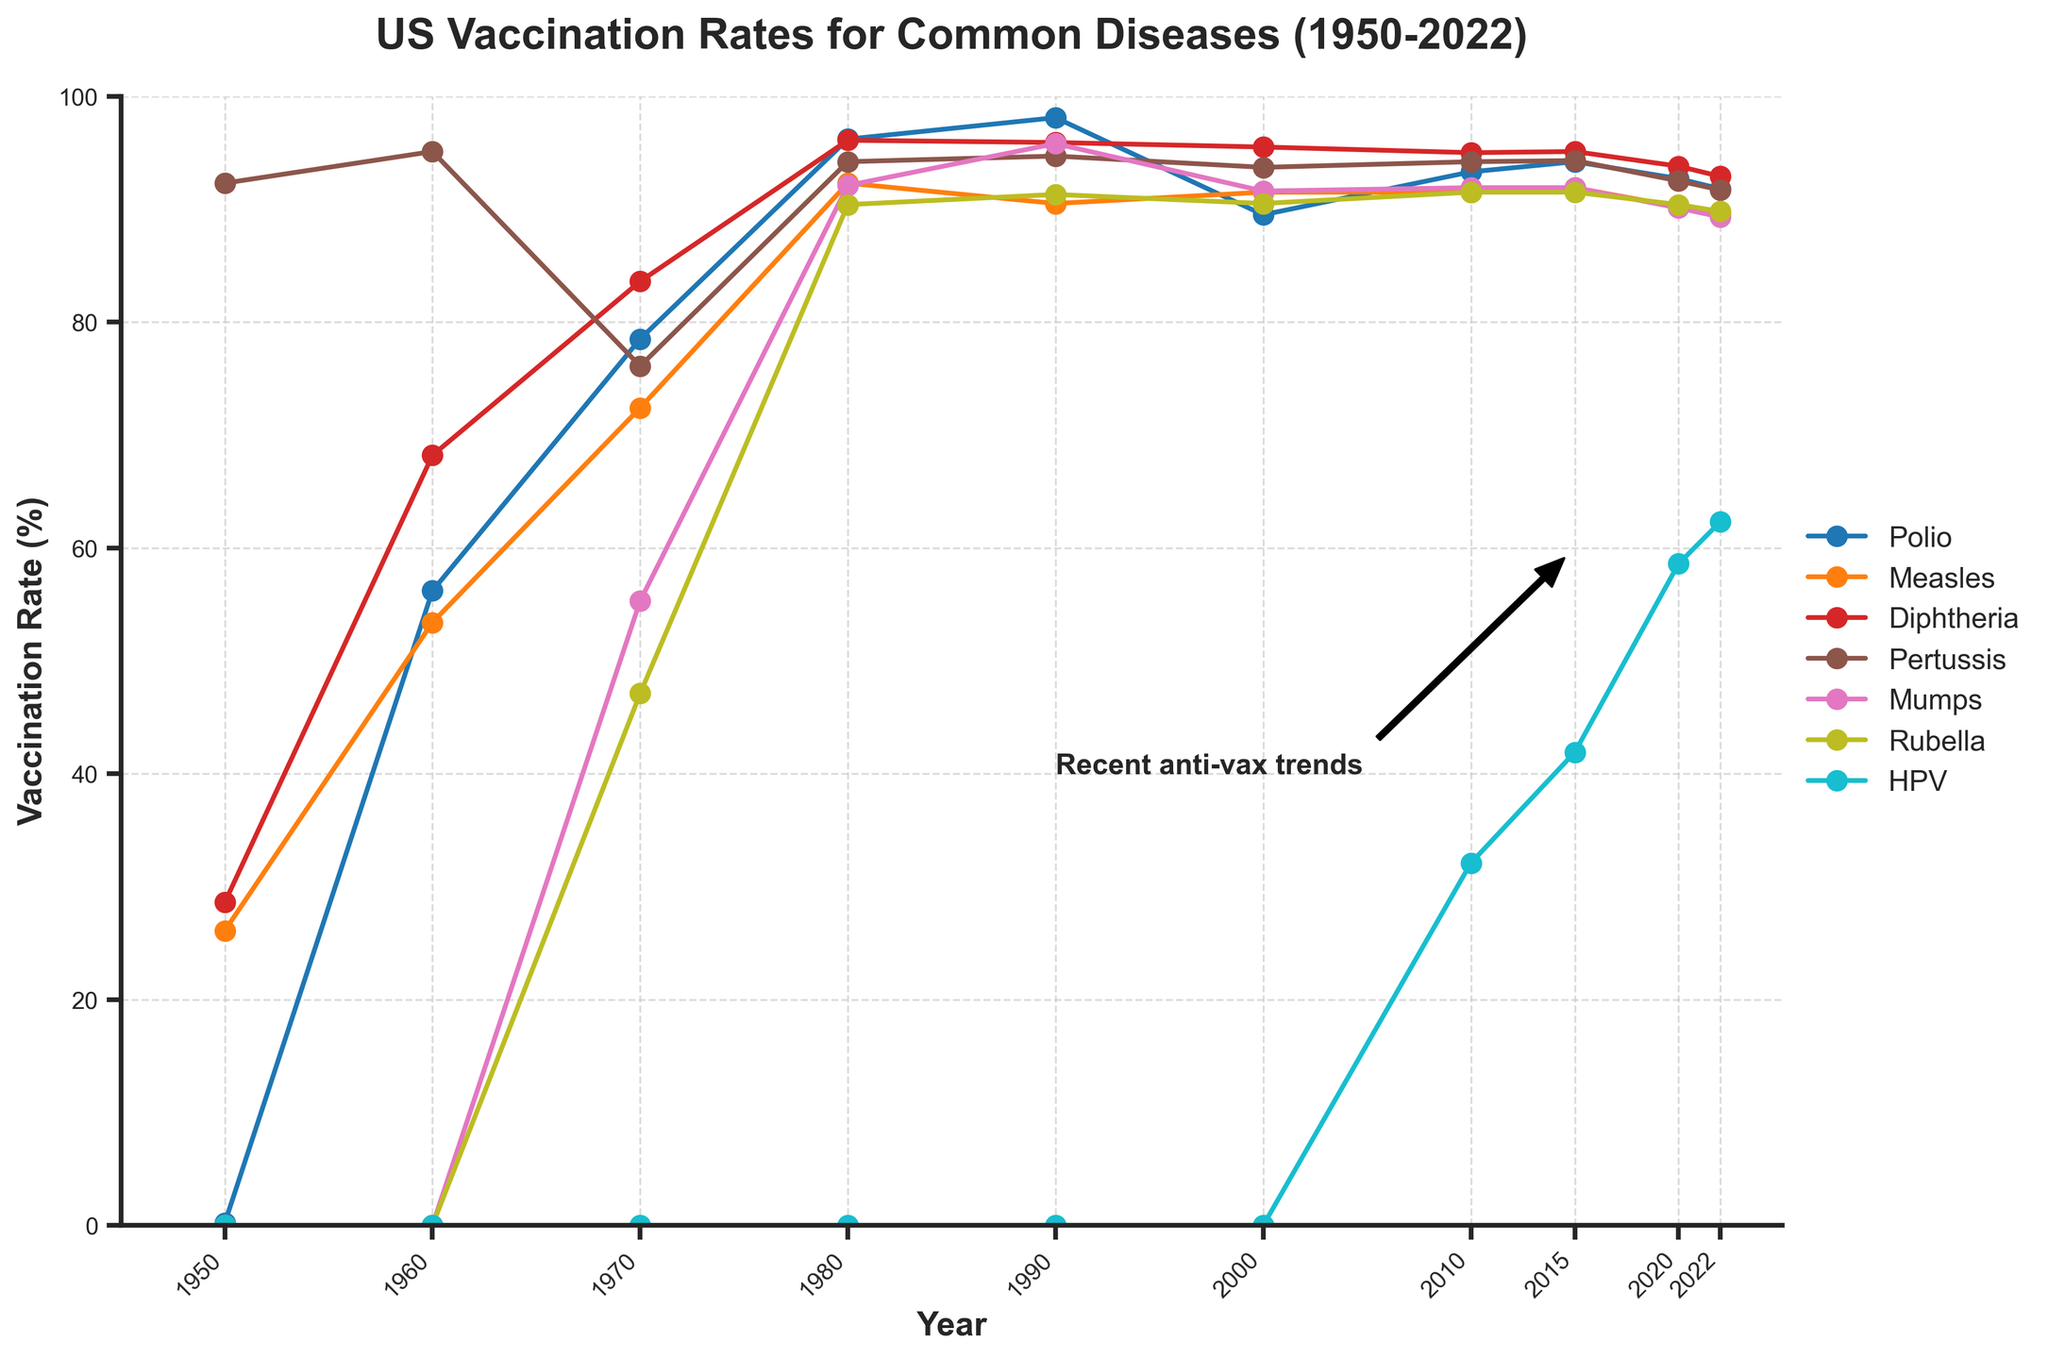What year did the Polio vaccination rate first exceed 90%? To find when the Polio vaccination rate first exceeded 90%, look at the specific points on the Polio line. The Polio vaccination rate surpassed 90% in 1980.
Answer: 1980 Which disease had the highest vaccination rate in 1960? In 1960, compare the data points for all diseases. The Polio vaccination rate was the highest at 56.2%.
Answer: Polio Between which years did the Rubella vaccination rate appear first, and how long did it take to reach above 90%? Rubella vaccination rate first appears in 1970 and reaches above 90% by 1980. So it took about 10 years.
Answer: 1970, 10 years Compare the Pertussis vaccination rates in 1970 and 2020. Which year had a higher rate? Observe the data points for Pertussis for the years 1970 and 2020. In 1970, the rate was 76.1%, while in 2020, it was 92.5%. 2020 had a higher rate.
Answer: 2020 Between 2015 and 2022, which vaccination rate showed the most significant decline? Compare the vaccination rates for all diseases between 2015 and 2022. Measles declined from 91.9% to 89.6%, a decrease of 2.3%.
Answer: Measles What is the average vaccination rate for Measles from 1950 to 2022? Calculate the average by summing up all Measles vaccination rates and dividing by the number of data points: (26.1 + 53.4 + 72.4 + 92.3 + 90.5 + 91.5 + 91.5 + 91.9 + 90.2 + 89.6)/10 = 78.94%.
Answer: 78.94% In what year did the HPV vaccination rate first get recorded, and what was its value then? Look at the line for HPV and find the first year it has a data point, which is 2010, with a value of 32.1%.
Answer: 2010, 32.1% What is the overall trend for vaccination rates from 1950 to the present for Rubella? The trend for Rubella appears to be an increase from its introduction in 1970 (47.1%) to a plateau around 90% in more recent years, followed by a slight decrease in 2022 to 89.8%.
Answer: Increasing, then slight decrease Which disease's vaccination rate changes the least between 2010 and 2022? Compare the differences in vaccination rates for each disease between 2010 and 2022. Mumps changed from 91.9% to 89.3%, which is a relatively small change of 2.6%.
Answer: Mumps List the top three years with the highest overall vaccination rate across all diseases shown. Calculate the average vaccination rate for all diseases for each year and compare. The years with the highest overall average rates are likely 1990, 1980, and 2015.
Answer: 1990, 1980, 2015 